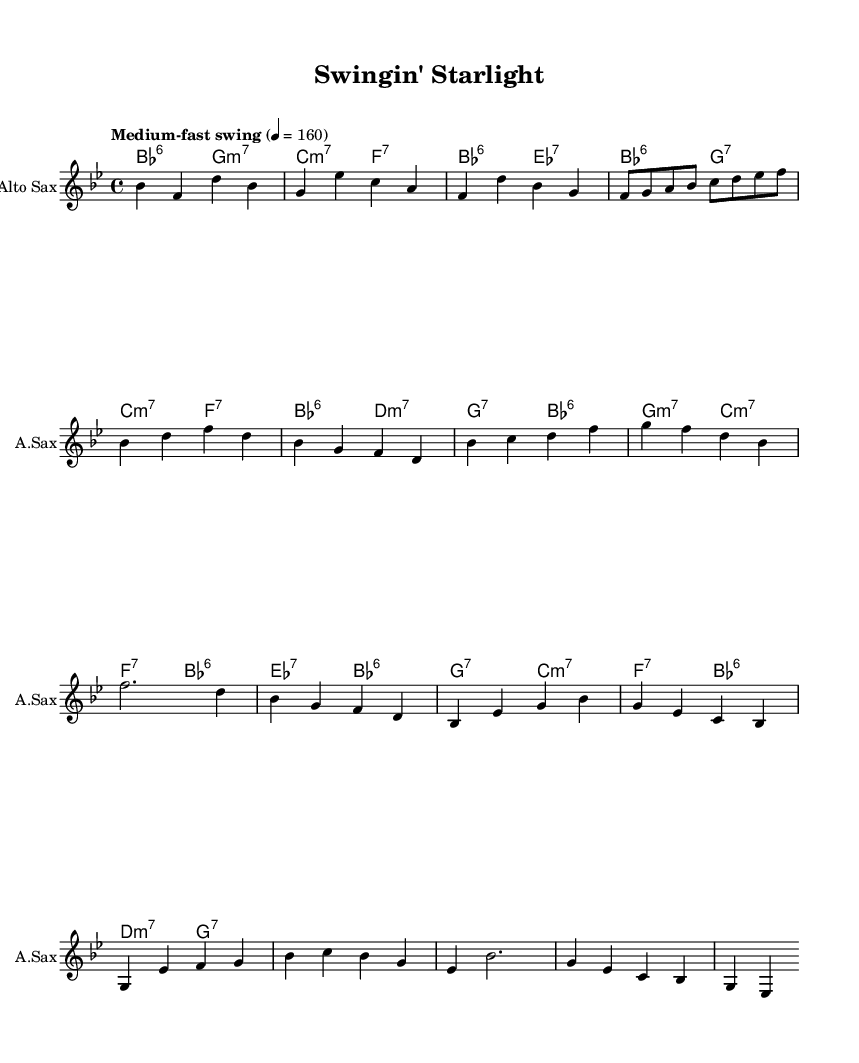What is the key signature of this music? The key signature indicates the music is in B flat major, which is characterized by two flats (B flat and E flat) indicated in the key signature section.
Answer: B flat major What is the time signature of this music? The time signature of 4/4 indicates there are four beats in each measure, and the quarter note gets one beat, as seen in the top part of the sheet music.
Answer: 4/4 What is the tempo marking of this piece? The tempo marking "Medium-fast swing" above the staff indicates the intended speed and style, with a metronome marking of 160 beats per minute.
Answer: Medium-fast swing How many measures are there in the A section of the music? The A section consists of two phrases, each with eight measures, totaling 16 measures overall. By counting the sections in the sheet music, we find the total.
Answer: 16 measures What is the main genre of this composition? The title "Swingin' Starlight" and the use of swing rhythms throughout the score suggest this is a swing jazz piece, which is a specific style of jazz music characterized by its rhythmic feel.
Answer: Swing jazz What type of chords are used in the B section? The B section predominantly utilizes 6th and minor 7th chords, as indicated in the chord symbols below the melody, such as B flat 6 and G minor 7.
Answer: 6th and minor 7th chords Are there any tied notes in the melody section? The melody includes tied notes indicated by a tie symbol connecting notes, showing that some notes should be held across the bar lines, particularly in the first A section.
Answer: Yes 